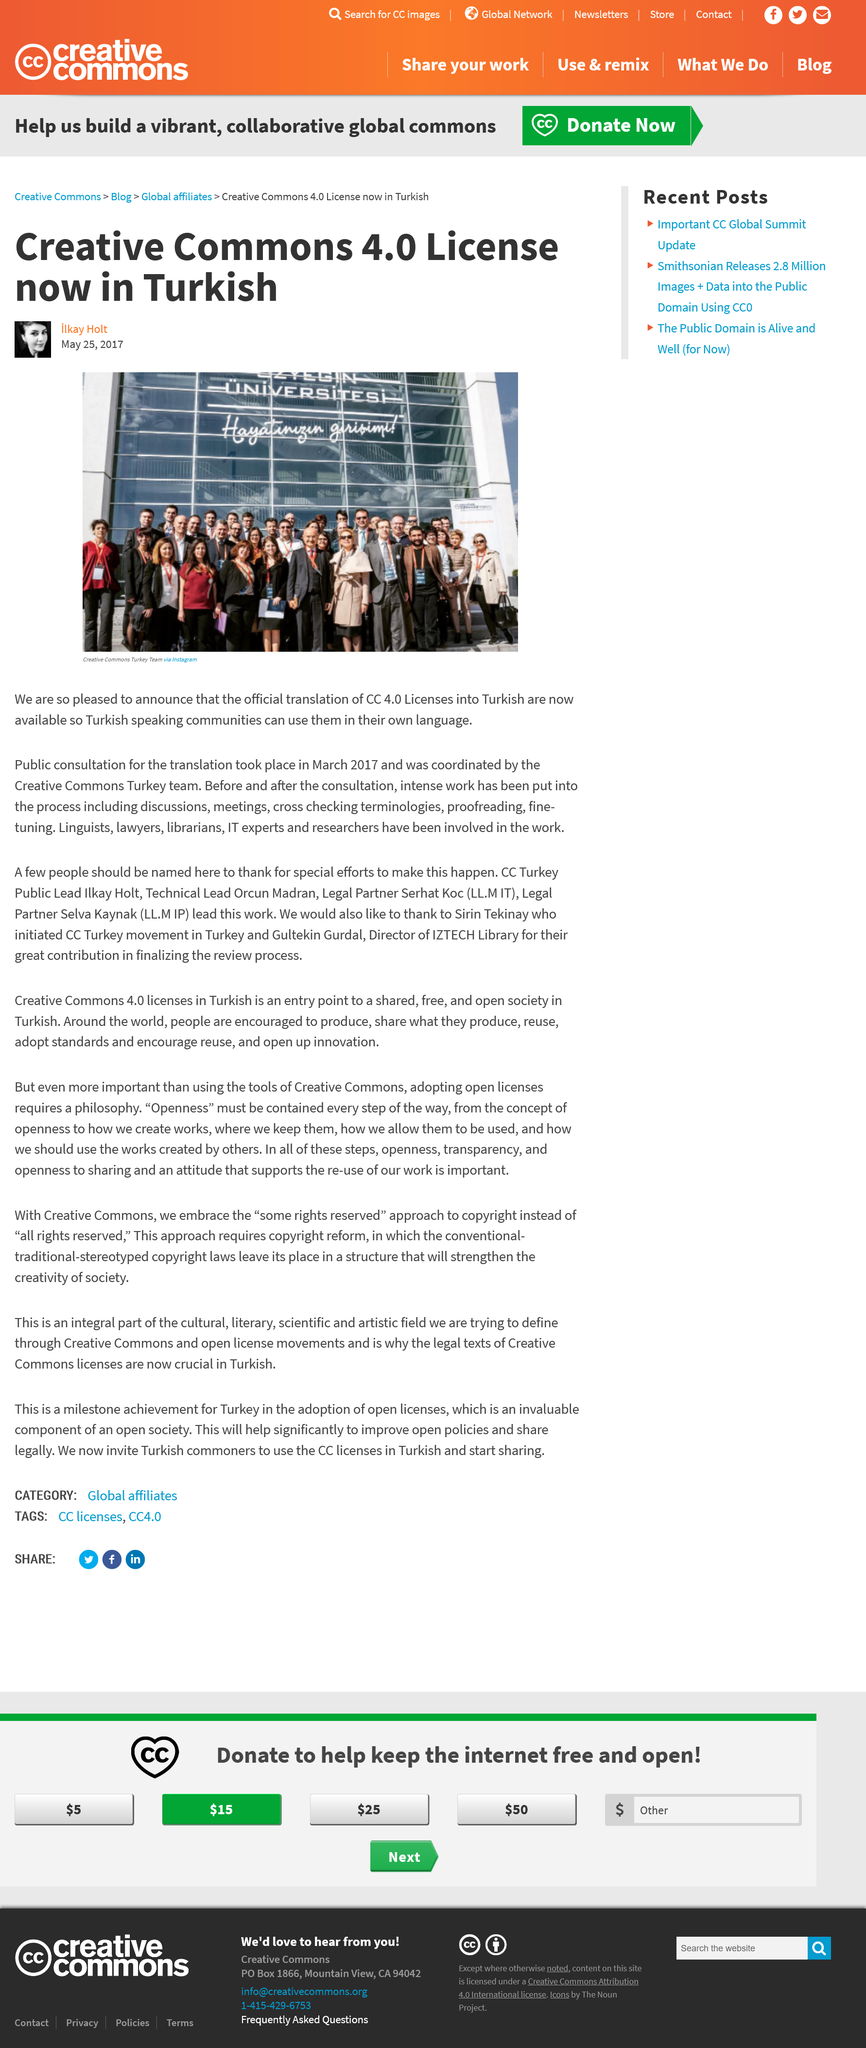Indicate a few pertinent items in this graphic. The intense work of discussions, meetings, cross checking, proofreading, and other processes was completed before and after the consultation. The public consultation for the translation took place in March 2017. The Creative Commons 4.0 license is now in Turkish. 